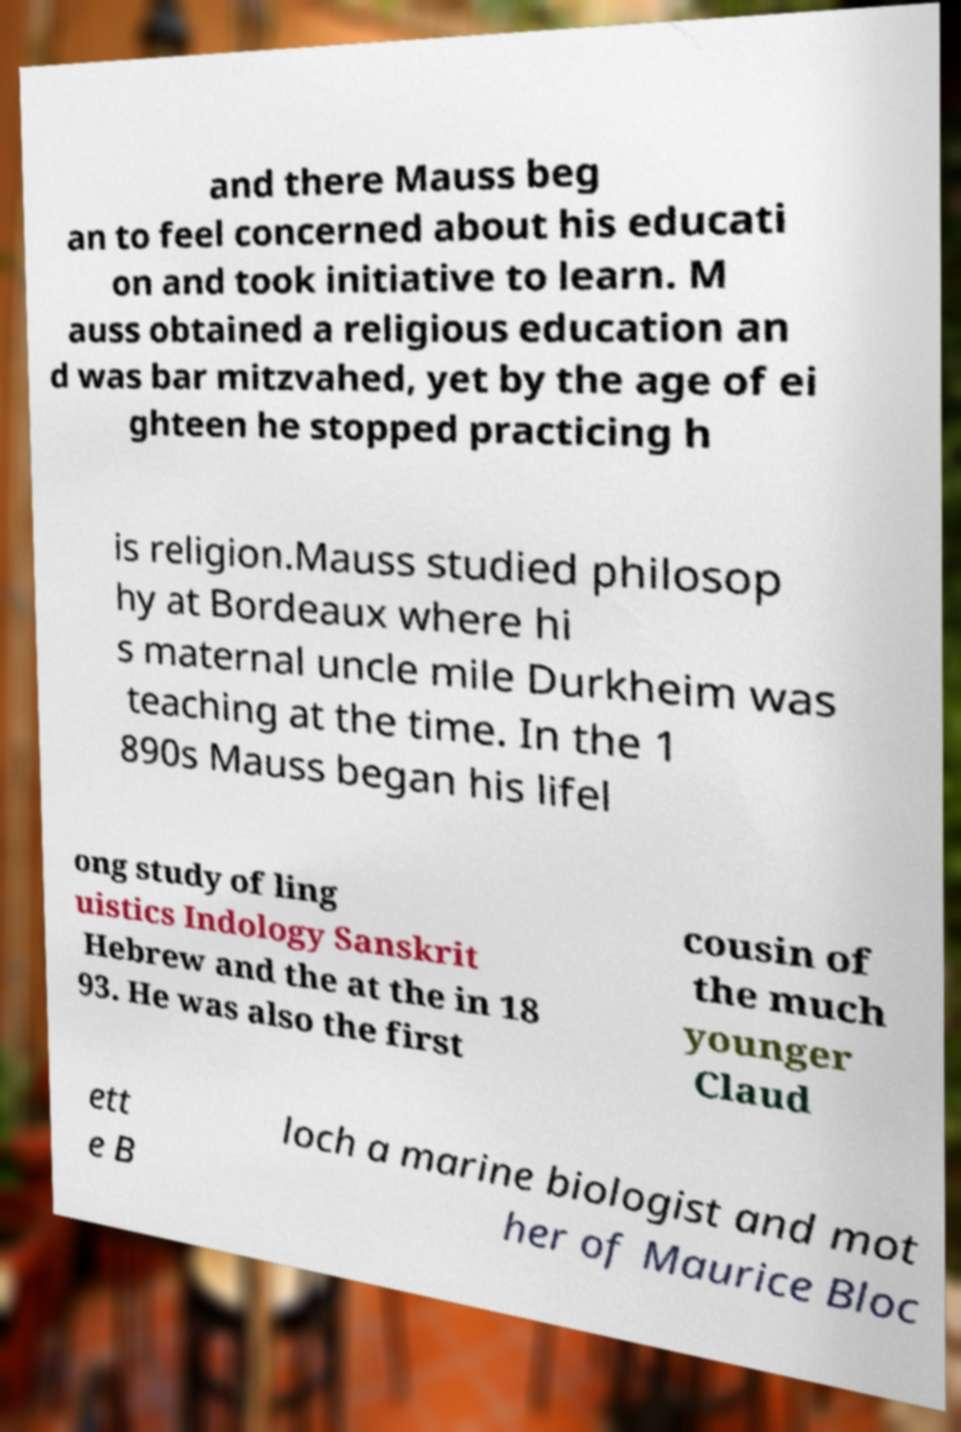Could you assist in decoding the text presented in this image and type it out clearly? and there Mauss beg an to feel concerned about his educati on and took initiative to learn. M auss obtained a religious education an d was bar mitzvahed, yet by the age of ei ghteen he stopped practicing h is religion.Mauss studied philosop hy at Bordeaux where hi s maternal uncle mile Durkheim was teaching at the time. In the 1 890s Mauss began his lifel ong study of ling uistics Indology Sanskrit Hebrew and the at the in 18 93. He was also the first cousin of the much younger Claud ett e B loch a marine biologist and mot her of Maurice Bloc 